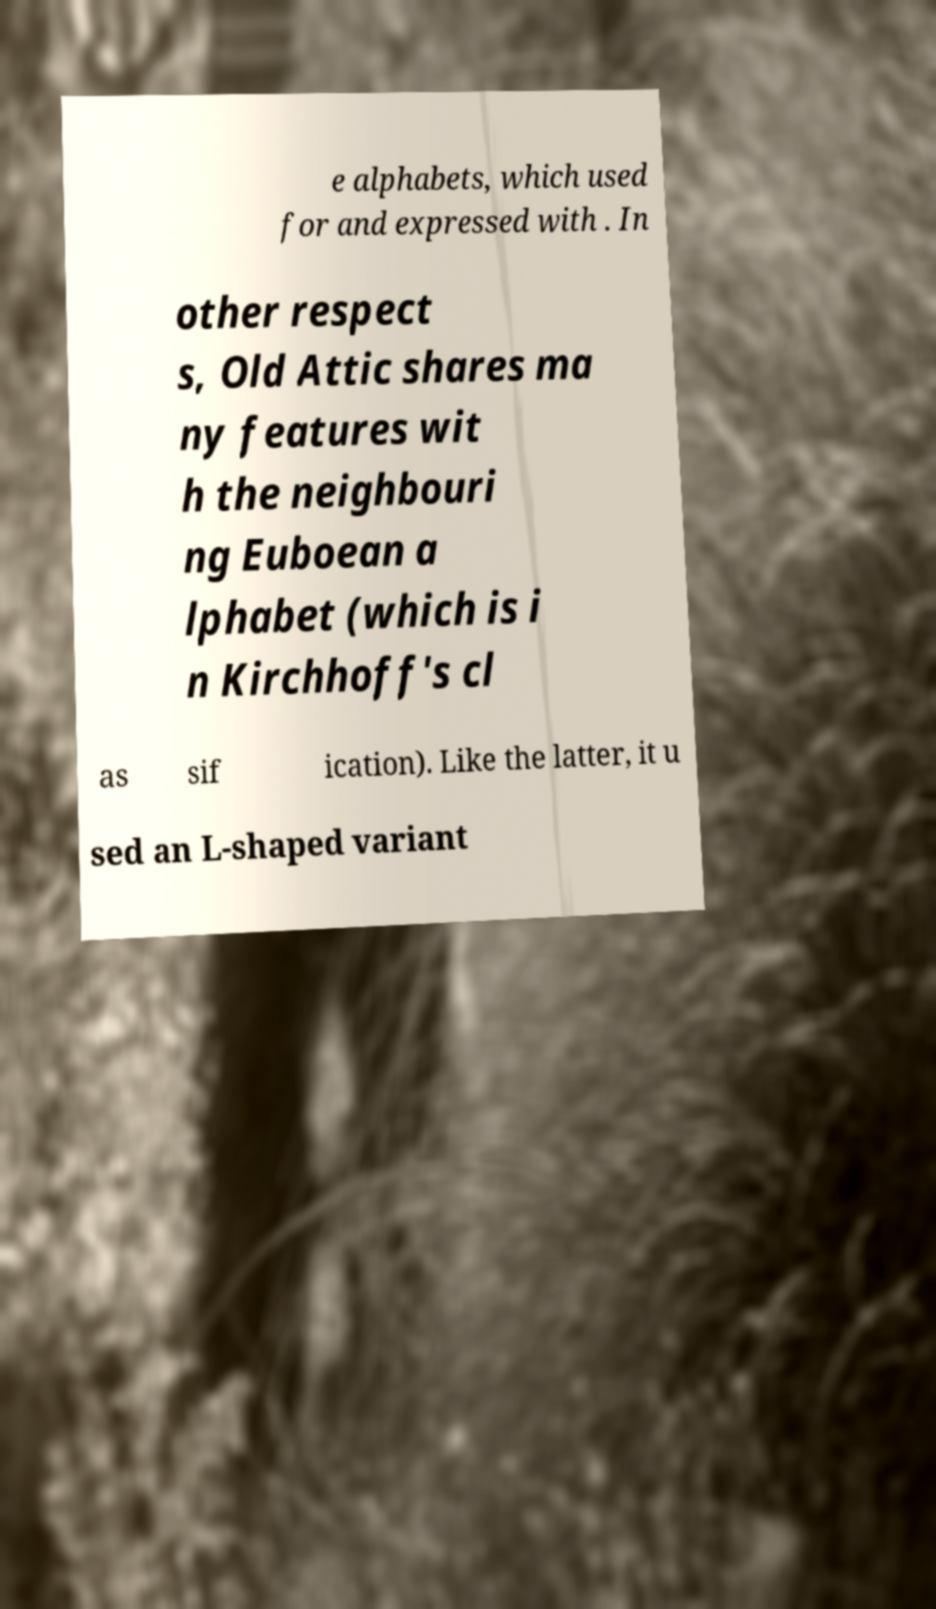Can you accurately transcribe the text from the provided image for me? e alphabets, which used for and expressed with . In other respect s, Old Attic shares ma ny features wit h the neighbouri ng Euboean a lphabet (which is i n Kirchhoff's cl as sif ication). Like the latter, it u sed an L-shaped variant 